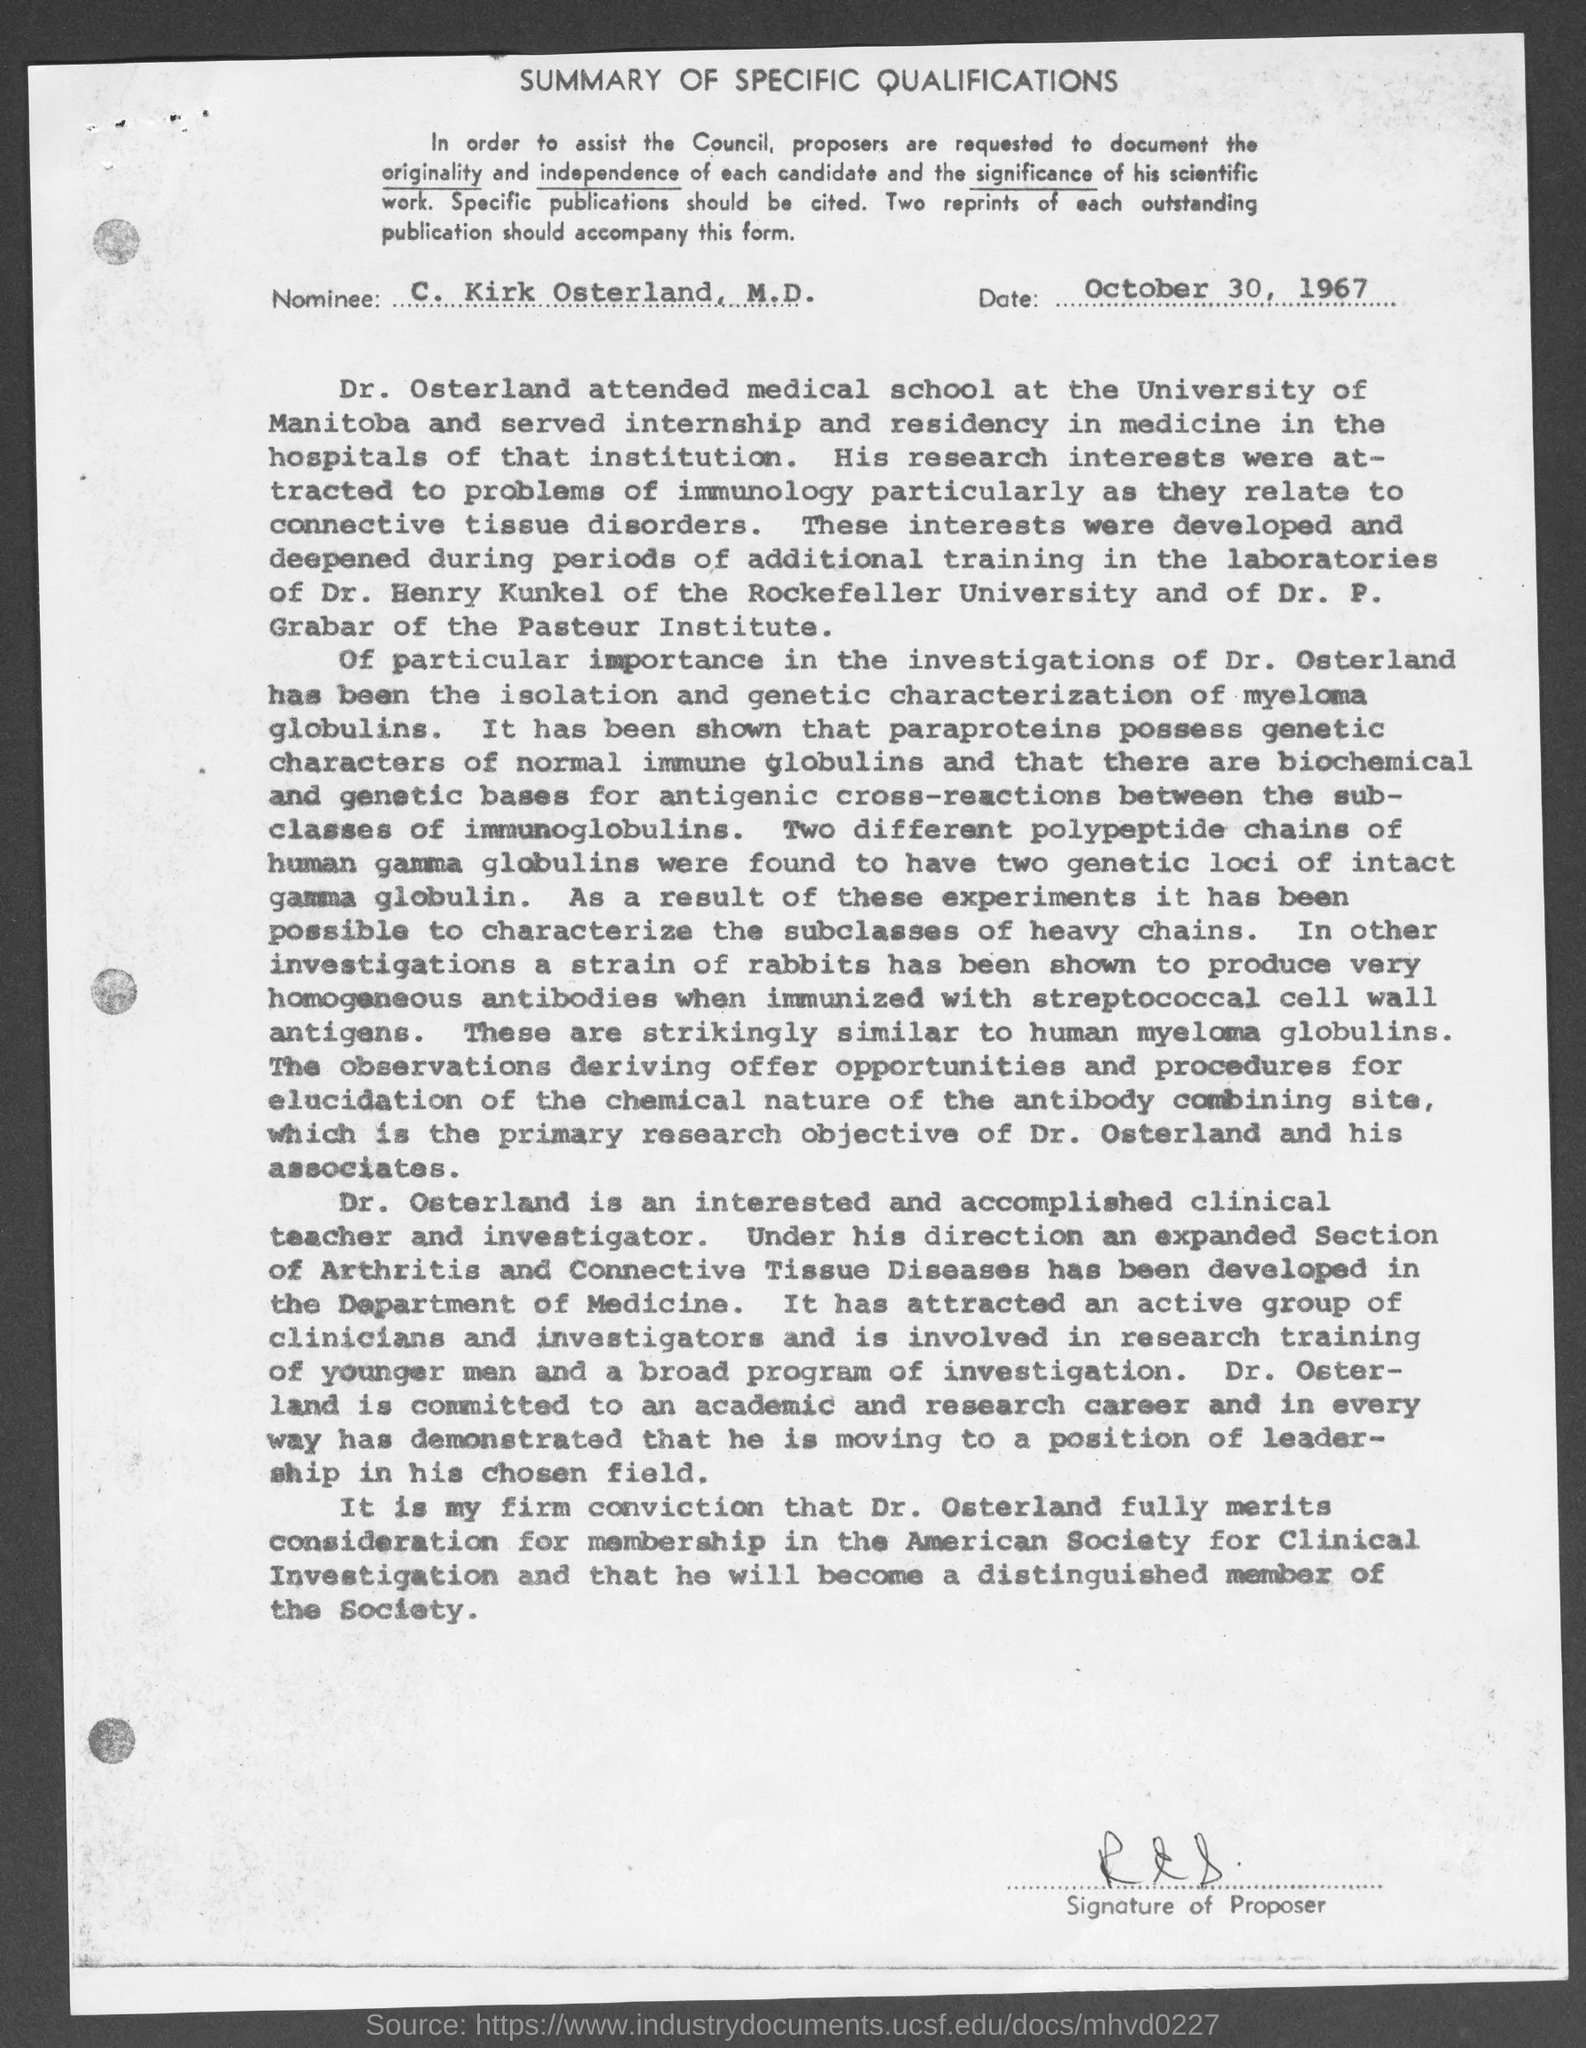Who is the nominee mentioned in the document?
Offer a very short reply. C. Kirk Osterland, M.D. What is the date mentioned in this document?
Provide a short and direct response. October 30, 1967. What is the title of this document?
Ensure brevity in your answer.  Summary of Specific Qualifications. 